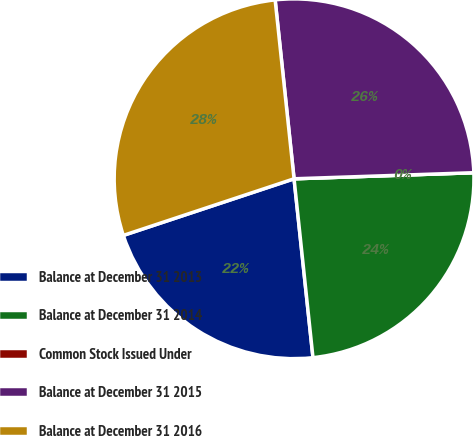Convert chart to OTSL. <chart><loc_0><loc_0><loc_500><loc_500><pie_chart><fcel>Balance at December 31 2013<fcel>Balance at December 31 2014<fcel>Common Stock Issued Under<fcel>Balance at December 31 2015<fcel>Balance at December 31 2016<nl><fcel>21.58%<fcel>23.86%<fcel>0.0%<fcel>26.14%<fcel>28.42%<nl></chart> 